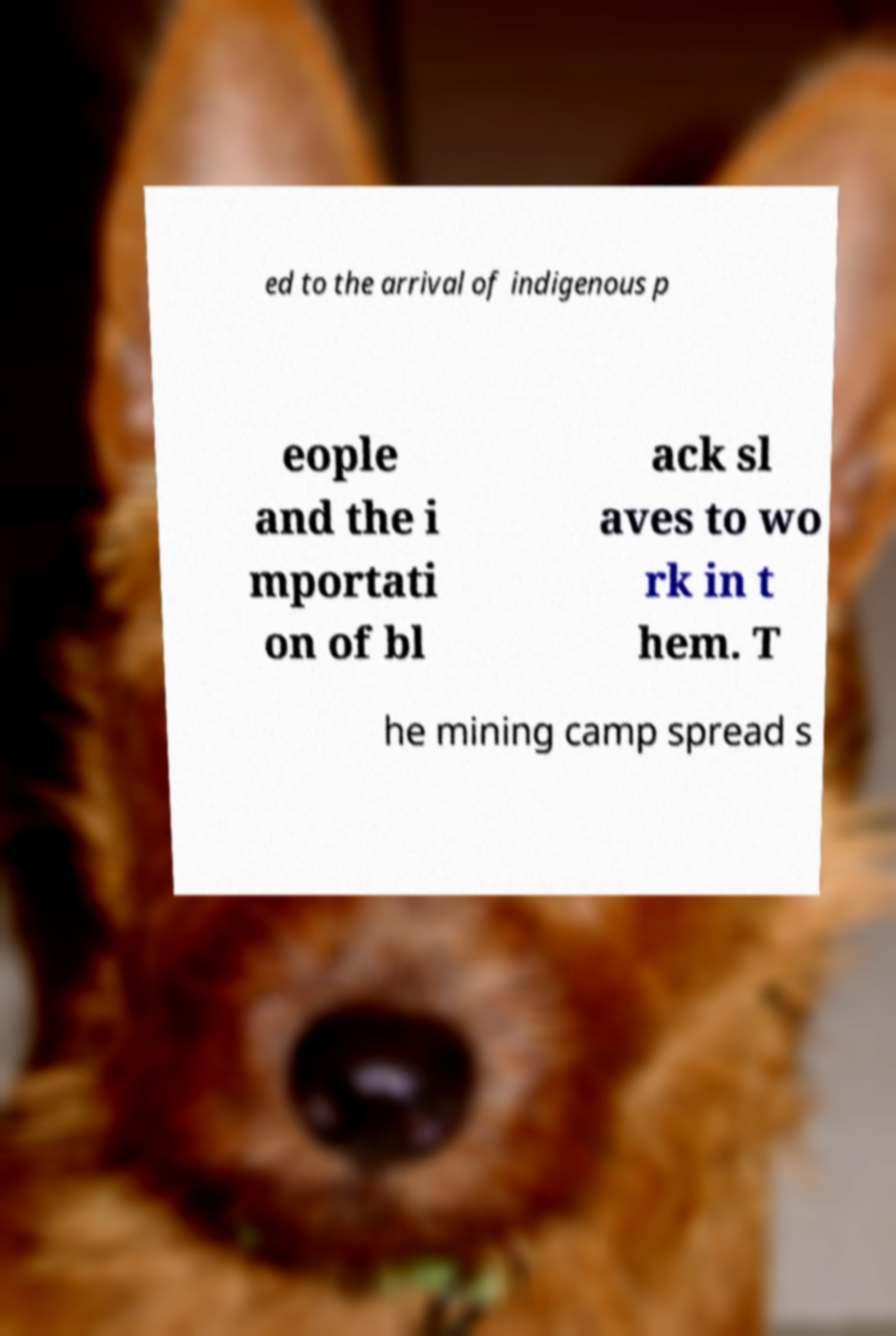Please read and relay the text visible in this image. What does it say? ed to the arrival of indigenous p eople and the i mportati on of bl ack sl aves to wo rk in t hem. T he mining camp spread s 